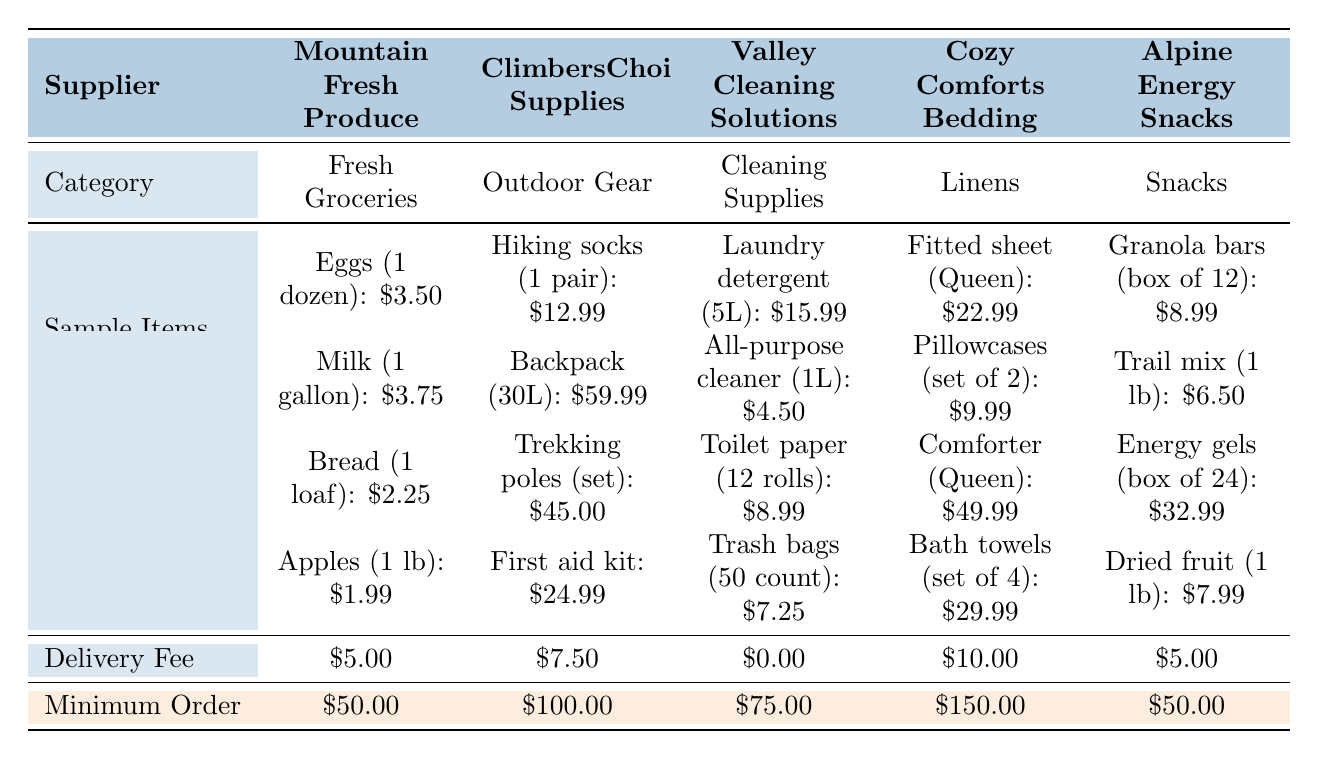What is the delivery fee for Valley Cleaning Solutions? The delivery fee for Valley Cleaning Solutions is specifically listed in the table. Looking under the Delivery Fee row for Valley Cleaning Solutions, it shows \$0.00.
Answer: 0.00 Which supplier has the highest minimum order requirement? The minimum order requirements for the suppliers are listed in the Minimum Order row. Comparing the values, Cozy Comforts Bedding has a minimum order of \$150, which is higher than others.
Answer: \$150.00 What is the total cost for one dozen eggs and a gallon of milk from Mountain Fresh Produce? The cost of one dozen eggs from Mountain Fresh Produce is \$3.50 and a gallon of milk is \$3.75. Adding them together, \$3.50 + \$3.75 gives a total of \$7.25.
Answer: \$7.25 Is the price of a comforter higher than the combined cost of two fitted sheets? A comforter (Queen) costs \$49.99 and a fitted sheet (Queen) costs \$22.99. Two fitted sheets would therefore be \$22.99 * 2 = \$45.98. Since \$49.99 is greater than \$45.98, the answer is yes.
Answer: Yes How much more expensive is the first aid kit compared to the all-purpose cleaner? The first aid kit costs \$24.99 and the all-purpose cleaner costs \$4.50. To find the price difference, subtract the cost of the all-purpose cleaner from that of the first aid kit: \$24.99 - \$4.50 = \$20.49.
Answer: \$20.49 Which supplier offers the cheapest cleaning supplies and what is the price of the cheapest item? Valley Cleaning Solutions offers cleaning supplies, and its cheapest item is the all-purpose cleaner at \$4.50. Comparing all suppliers, Valley Cleaning Solutions has the lowest overall average price for its cleaning items as well.
Answer: \$4.50 What is the average price of the sample items offered by Alpine Energy Snacks? The prices of the sample items from Alpine Energy Snacks are \$8.99, \$6.50, \$32.99, and \$7.99. Adding them up gives \$8.99 + \$6.50 + \$32.99 + \$7.99 = \$56.47. Dividing this total by the number of items (4) gives an average of \$14.12.
Answer: \$14.12 Does Cozy Comforts Bedding have a delivery fee? Cozy Comforts Bedding's delivery fee is listed in the Delivery Fee row, and it shows \$10.00. Hence, the answer to whether it has a delivery fee is yes, because there is a charge associated.
Answer: Yes What is the combined minimum order requirement for Mountain Fresh Produce and Alpine Energy Snacks? The minimum order for Mountain Fresh Produce is \$50.00 and for Alpine Energy Snacks it's also \$50.00. Adding these two minimum orders together gives \$50.00 + \$50.00 = \$100.00.
Answer: \$100.00 